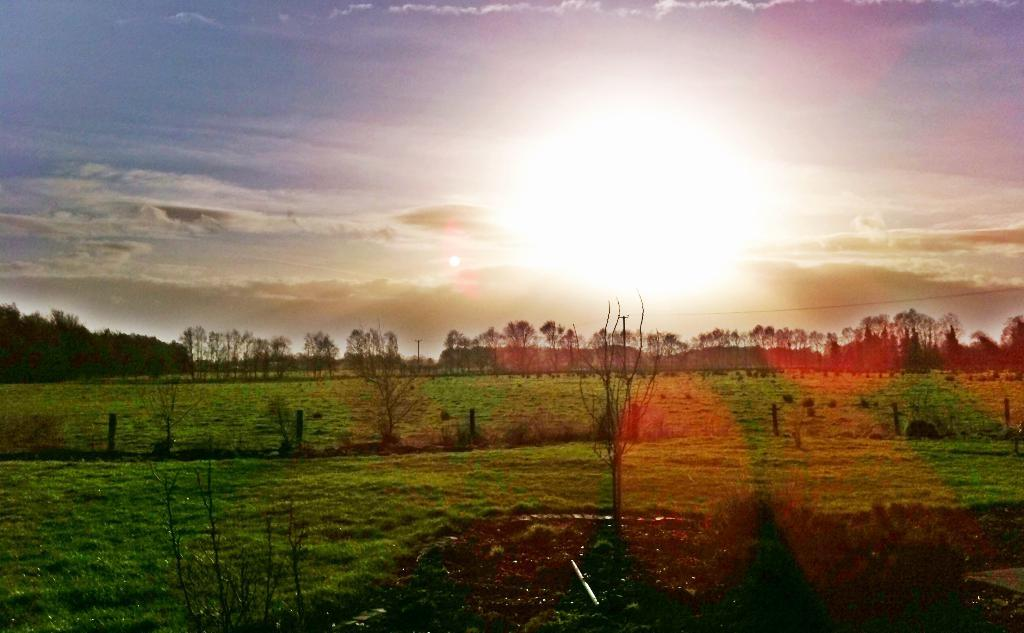What type of surface is visible in the image? There is a grass surface in the image. What can be seen growing on the grass surface? There are plants on the grass surface. What is visible in the background of the image? There are trees in the background of the image. What can be seen in the sky in the image? The sky is visible in the image, and clouds and the sun are present. What type of belief system is depicted in the image? There is no indication of a belief system in the image; it features a grass surface, plants, trees, and a sky with clouds and the sun. What scientific experiments are being conducted in the image? There is no indication of scientific experiments being conducted in the image; it features a grass surface, plants, trees, and a sky with clouds and the sun. 